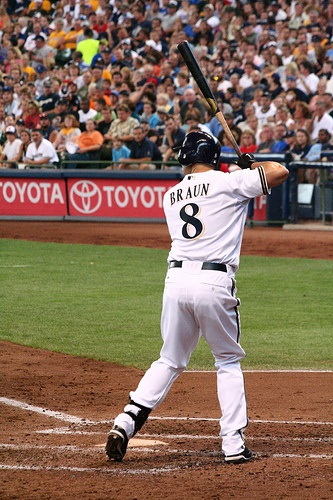Describe the objects in this image and their specific colors. I can see people in black, brown, gray, and maroon tones, people in black, lavender, darkgray, and gray tones, baseball bat in black, gray, and maroon tones, people in black, brown, gray, and maroon tones, and people in black, salmon, red, and brown tones in this image. 